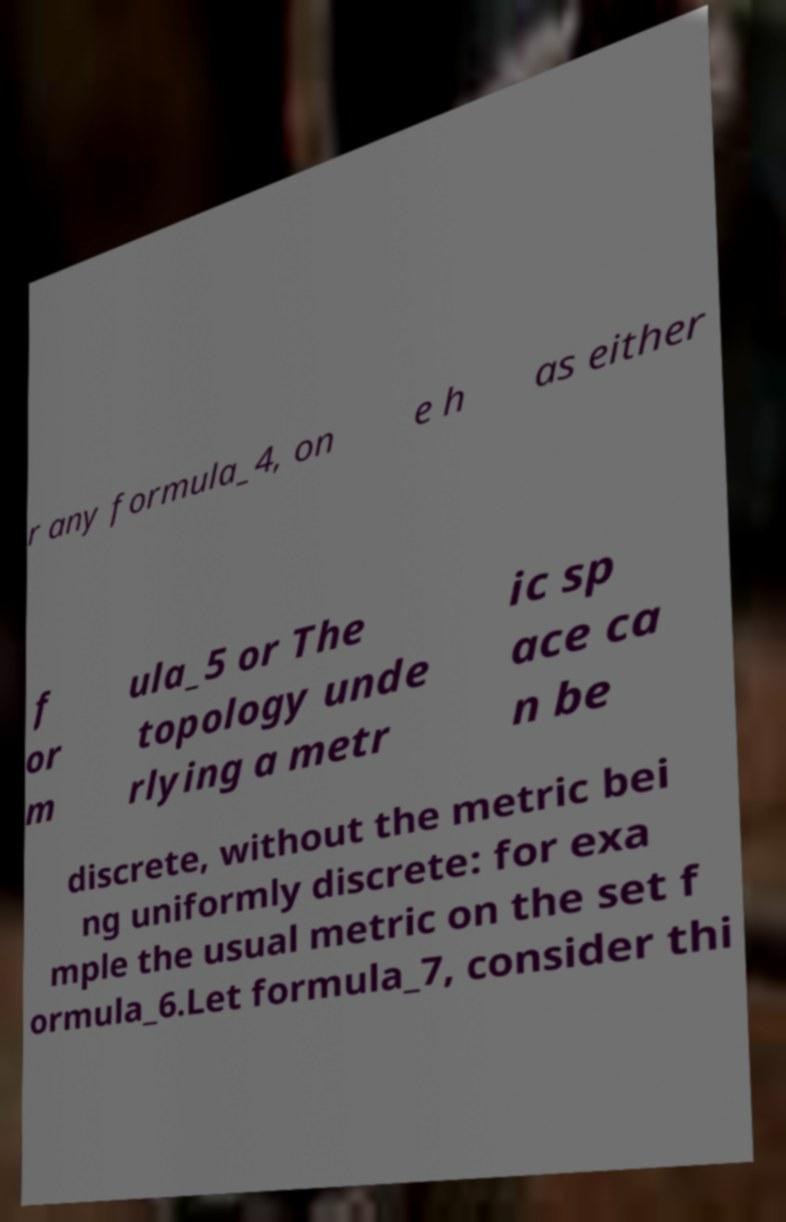Can you read and provide the text displayed in the image?This photo seems to have some interesting text. Can you extract and type it out for me? r any formula_4, on e h as either f or m ula_5 or The topology unde rlying a metr ic sp ace ca n be discrete, without the metric bei ng uniformly discrete: for exa mple the usual metric on the set f ormula_6.Let formula_7, consider thi 